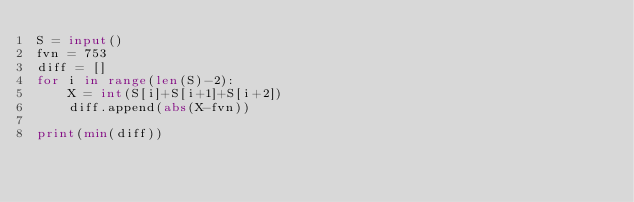<code> <loc_0><loc_0><loc_500><loc_500><_Python_>S = input()
fvn = 753
diff = []
for i in range(len(S)-2):
    X = int(S[i]+S[i+1]+S[i+2])
    diff.append(abs(X-fvn))

print(min(diff))</code> 